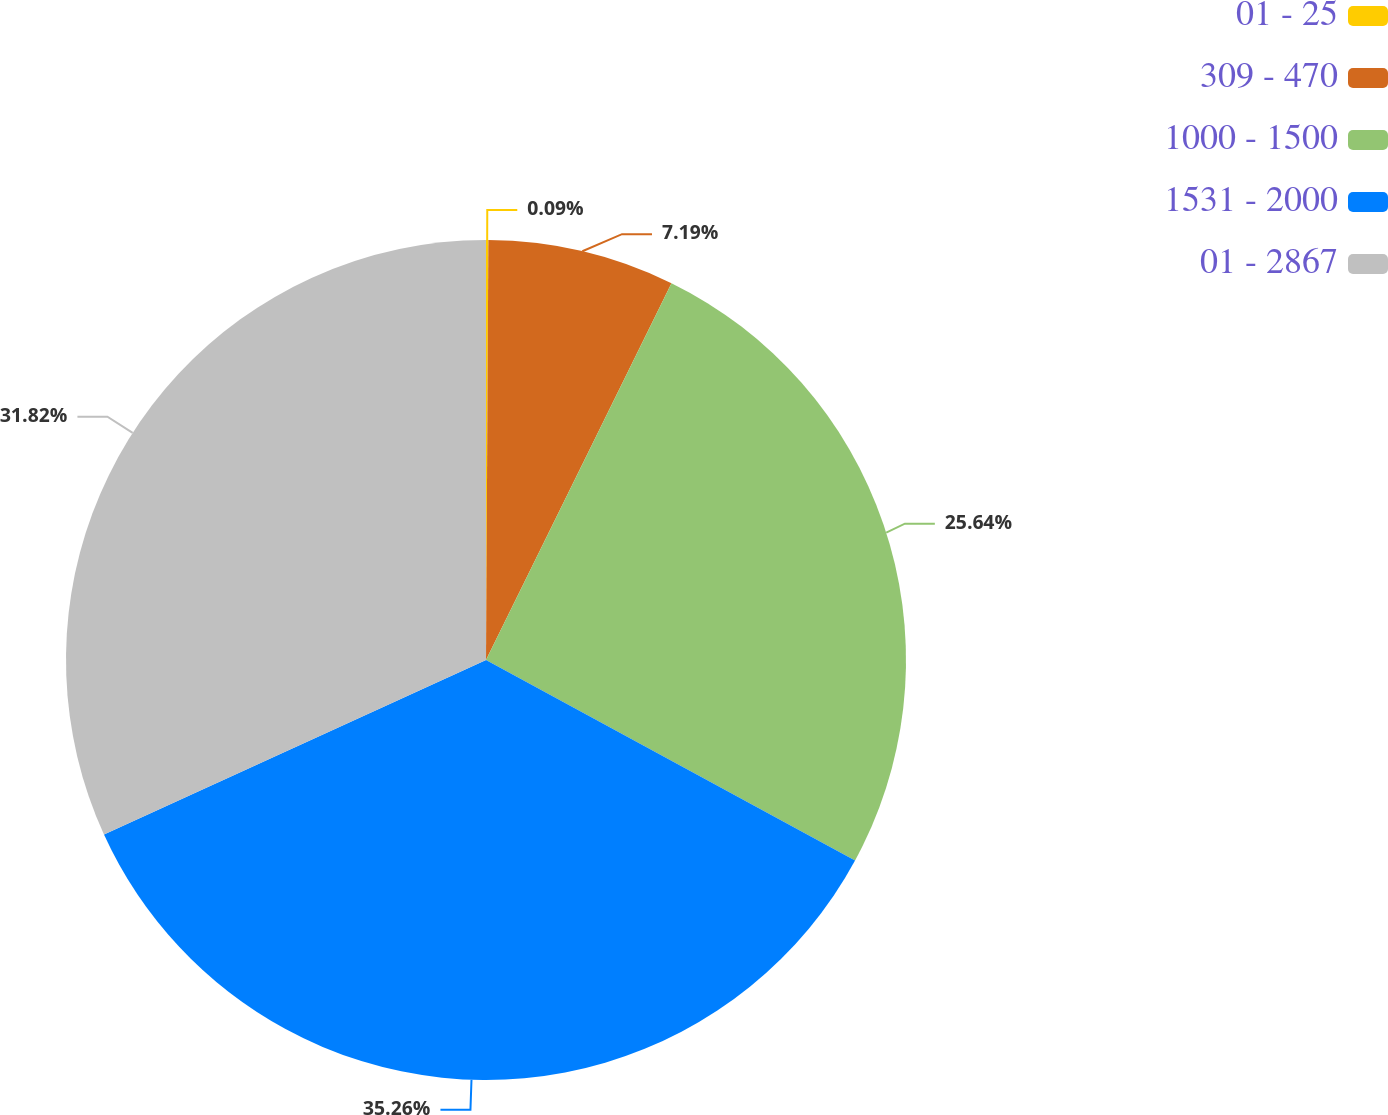<chart> <loc_0><loc_0><loc_500><loc_500><pie_chart><fcel>01 - 25<fcel>309 - 470<fcel>1000 - 1500<fcel>1531 - 2000<fcel>01 - 2867<nl><fcel>0.09%<fcel>7.19%<fcel>25.64%<fcel>35.26%<fcel>31.82%<nl></chart> 